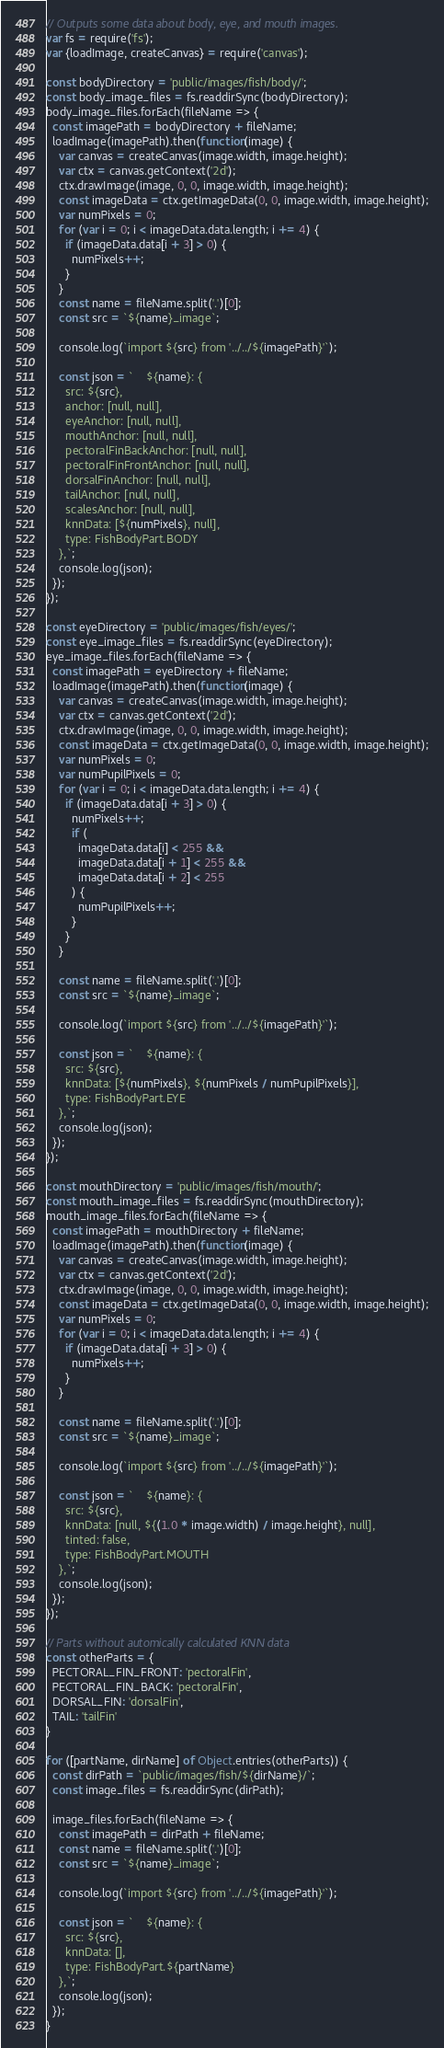Convert code to text. <code><loc_0><loc_0><loc_500><loc_500><_JavaScript_>// Outputs some data about body, eye, and mouth images.
var fs = require('fs');
var {loadImage, createCanvas} = require('canvas');

const bodyDirectory = 'public/images/fish/body/';
const body_image_files = fs.readdirSync(bodyDirectory);
body_image_files.forEach(fileName => {
  const imagePath = bodyDirectory + fileName;
  loadImage(imagePath).then(function(image) {
    var canvas = createCanvas(image.width, image.height);
    var ctx = canvas.getContext('2d');
    ctx.drawImage(image, 0, 0, image.width, image.height);
    const imageData = ctx.getImageData(0, 0, image.width, image.height);
    var numPixels = 0;
    for (var i = 0; i < imageData.data.length; i += 4) {
      if (imageData.data[i + 3] > 0) {
        numPixels++;
      }
    }
    const name = fileName.split('.')[0];
    const src = `${name}_image`;

    console.log(`import ${src} from '../../${imagePath}'`);

    const json = `    ${name}: {
      src: ${src},
      anchor: [null, null],
      eyeAnchor: [null, null],
      mouthAnchor: [null, null],
      pectoralFinBackAnchor: [null, null],
      pectoralFinFrontAnchor: [null, null],
      dorsalFinAnchor: [null, null],
      tailAnchor: [null, null],
      scalesAnchor: [null, null],
      knnData: [${numPixels}, null],
      type: FishBodyPart.BODY
    },`;
    console.log(json);
  });
});

const eyeDirectory = 'public/images/fish/eyes/';
const eye_image_files = fs.readdirSync(eyeDirectory);
eye_image_files.forEach(fileName => {
  const imagePath = eyeDirectory + fileName;
  loadImage(imagePath).then(function(image) {
    var canvas = createCanvas(image.width, image.height);
    var ctx = canvas.getContext('2d');
    ctx.drawImage(image, 0, 0, image.width, image.height);
    const imageData = ctx.getImageData(0, 0, image.width, image.height);
    var numPixels = 0;
    var numPupilPixels = 0;
    for (var i = 0; i < imageData.data.length; i += 4) {
      if (imageData.data[i + 3] > 0) {
        numPixels++;
        if (
          imageData.data[i] < 255 &&
          imageData.data[i + 1] < 255 &&
          imageData.data[i + 2] < 255
        ) {
          numPupilPixels++;
        }
      }
    }

    const name = fileName.split('.')[0];
    const src = `${name}_image`;

    console.log(`import ${src} from '../../${imagePath}'`);

    const json = `    ${name}: {
      src: ${src},
      knnData: [${numPixels}, ${numPixels / numPupilPixels}],
      type: FishBodyPart.EYE
    },`;
    console.log(json);
  });
});

const mouthDirectory = 'public/images/fish/mouth/';
const mouth_image_files = fs.readdirSync(mouthDirectory);
mouth_image_files.forEach(fileName => {
  const imagePath = mouthDirectory + fileName;
  loadImage(imagePath).then(function(image) {
    var canvas = createCanvas(image.width, image.height);
    var ctx = canvas.getContext('2d');
    ctx.drawImage(image, 0, 0, image.width, image.height);
    const imageData = ctx.getImageData(0, 0, image.width, image.height);
    var numPixels = 0;
    for (var i = 0; i < imageData.data.length; i += 4) {
      if (imageData.data[i + 3] > 0) {
        numPixels++;
      }
    }

    const name = fileName.split('.')[0];
    const src = `${name}_image`;

    console.log(`import ${src} from '../../${imagePath}'`);

    const json = `    ${name}: {
      src: ${src},
      knnData: [null, ${(1.0 * image.width) / image.height}, null],
      tinted: false,
      type: FishBodyPart.MOUTH
    },`;
    console.log(json);
  });
});

// Parts without automically calculated KNN data
const otherParts = {
  PECTORAL_FIN_FRONT: 'pectoralFin',
  PECTORAL_FIN_BACK: 'pectoralFin',
  DORSAL_FIN: 'dorsalFin',
  TAIL: 'tailFin'
}

for ([partName, dirName] of Object.entries(otherParts)) {
  const dirPath = `public/images/fish/${dirName}/`;
  const image_files = fs.readdirSync(dirPath);

  image_files.forEach(fileName => {
    const imagePath = dirPath + fileName;
    const name = fileName.split('.')[0];
    const src = `${name}_image`;

    console.log(`import ${src} from '../../${imagePath}'`);

    const json = `    ${name}: {
      src: ${src},
      knnData: [],
      type: FishBodyPart.${partName}
    },`;
    console.log(json);
  });
}
</code> 